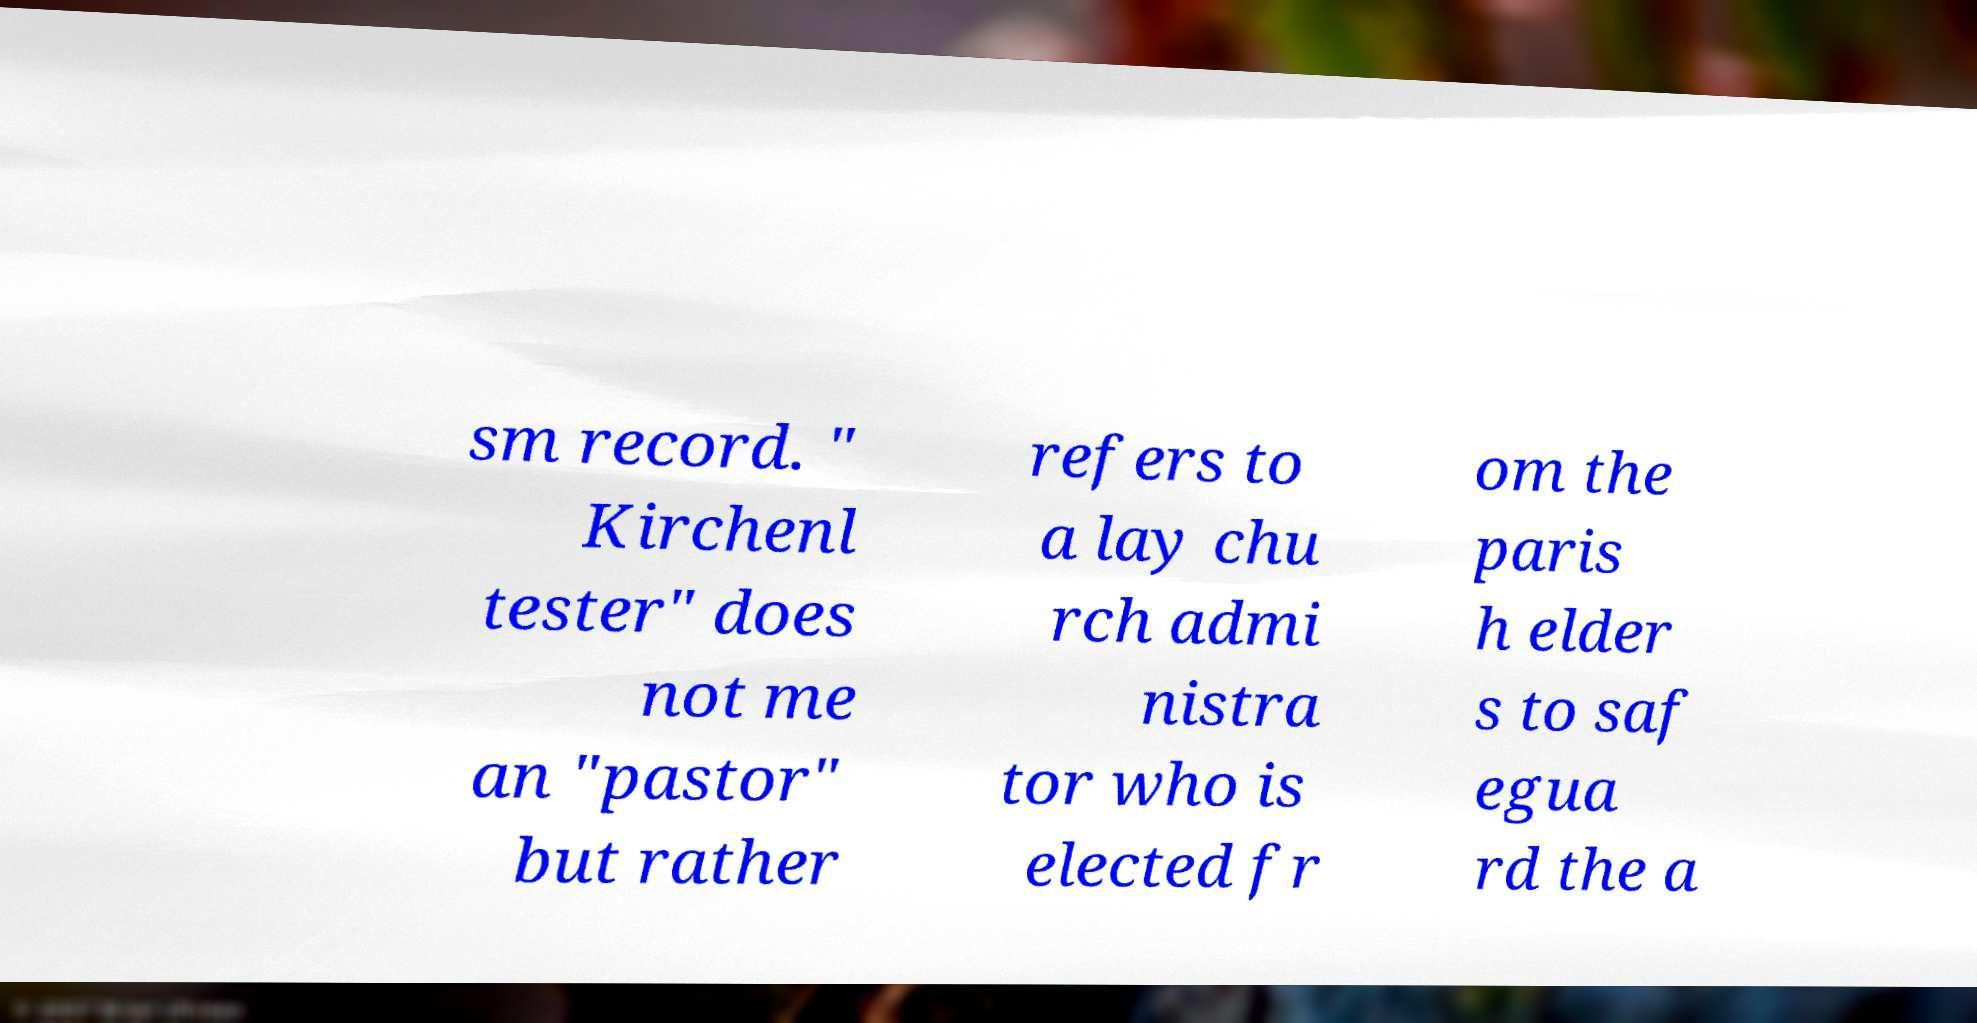Can you read and provide the text displayed in the image?This photo seems to have some interesting text. Can you extract and type it out for me? sm record. " Kirchenl tester" does not me an "pastor" but rather refers to a lay chu rch admi nistra tor who is elected fr om the paris h elder s to saf egua rd the a 